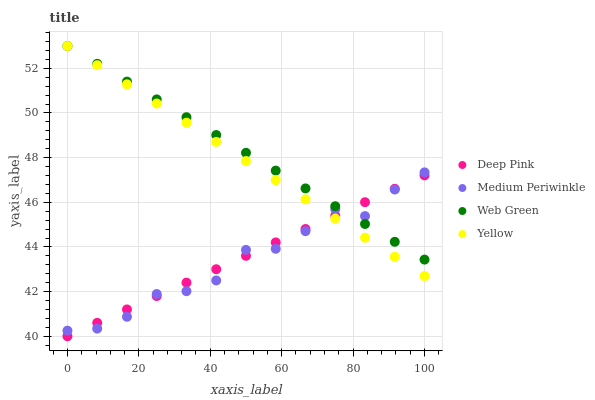Does Medium Periwinkle have the minimum area under the curve?
Answer yes or no. Yes. Does Web Green have the maximum area under the curve?
Answer yes or no. Yes. Does Yellow have the minimum area under the curve?
Answer yes or no. No. Does Yellow have the maximum area under the curve?
Answer yes or no. No. Is Yellow the smoothest?
Answer yes or no. Yes. Is Medium Periwinkle the roughest?
Answer yes or no. Yes. Is Medium Periwinkle the smoothest?
Answer yes or no. No. Is Yellow the roughest?
Answer yes or no. No. Does Deep Pink have the lowest value?
Answer yes or no. Yes. Does Medium Periwinkle have the lowest value?
Answer yes or no. No. Does Web Green have the highest value?
Answer yes or no. Yes. Does Medium Periwinkle have the highest value?
Answer yes or no. No. Does Web Green intersect Medium Periwinkle?
Answer yes or no. Yes. Is Web Green less than Medium Periwinkle?
Answer yes or no. No. Is Web Green greater than Medium Periwinkle?
Answer yes or no. No. 